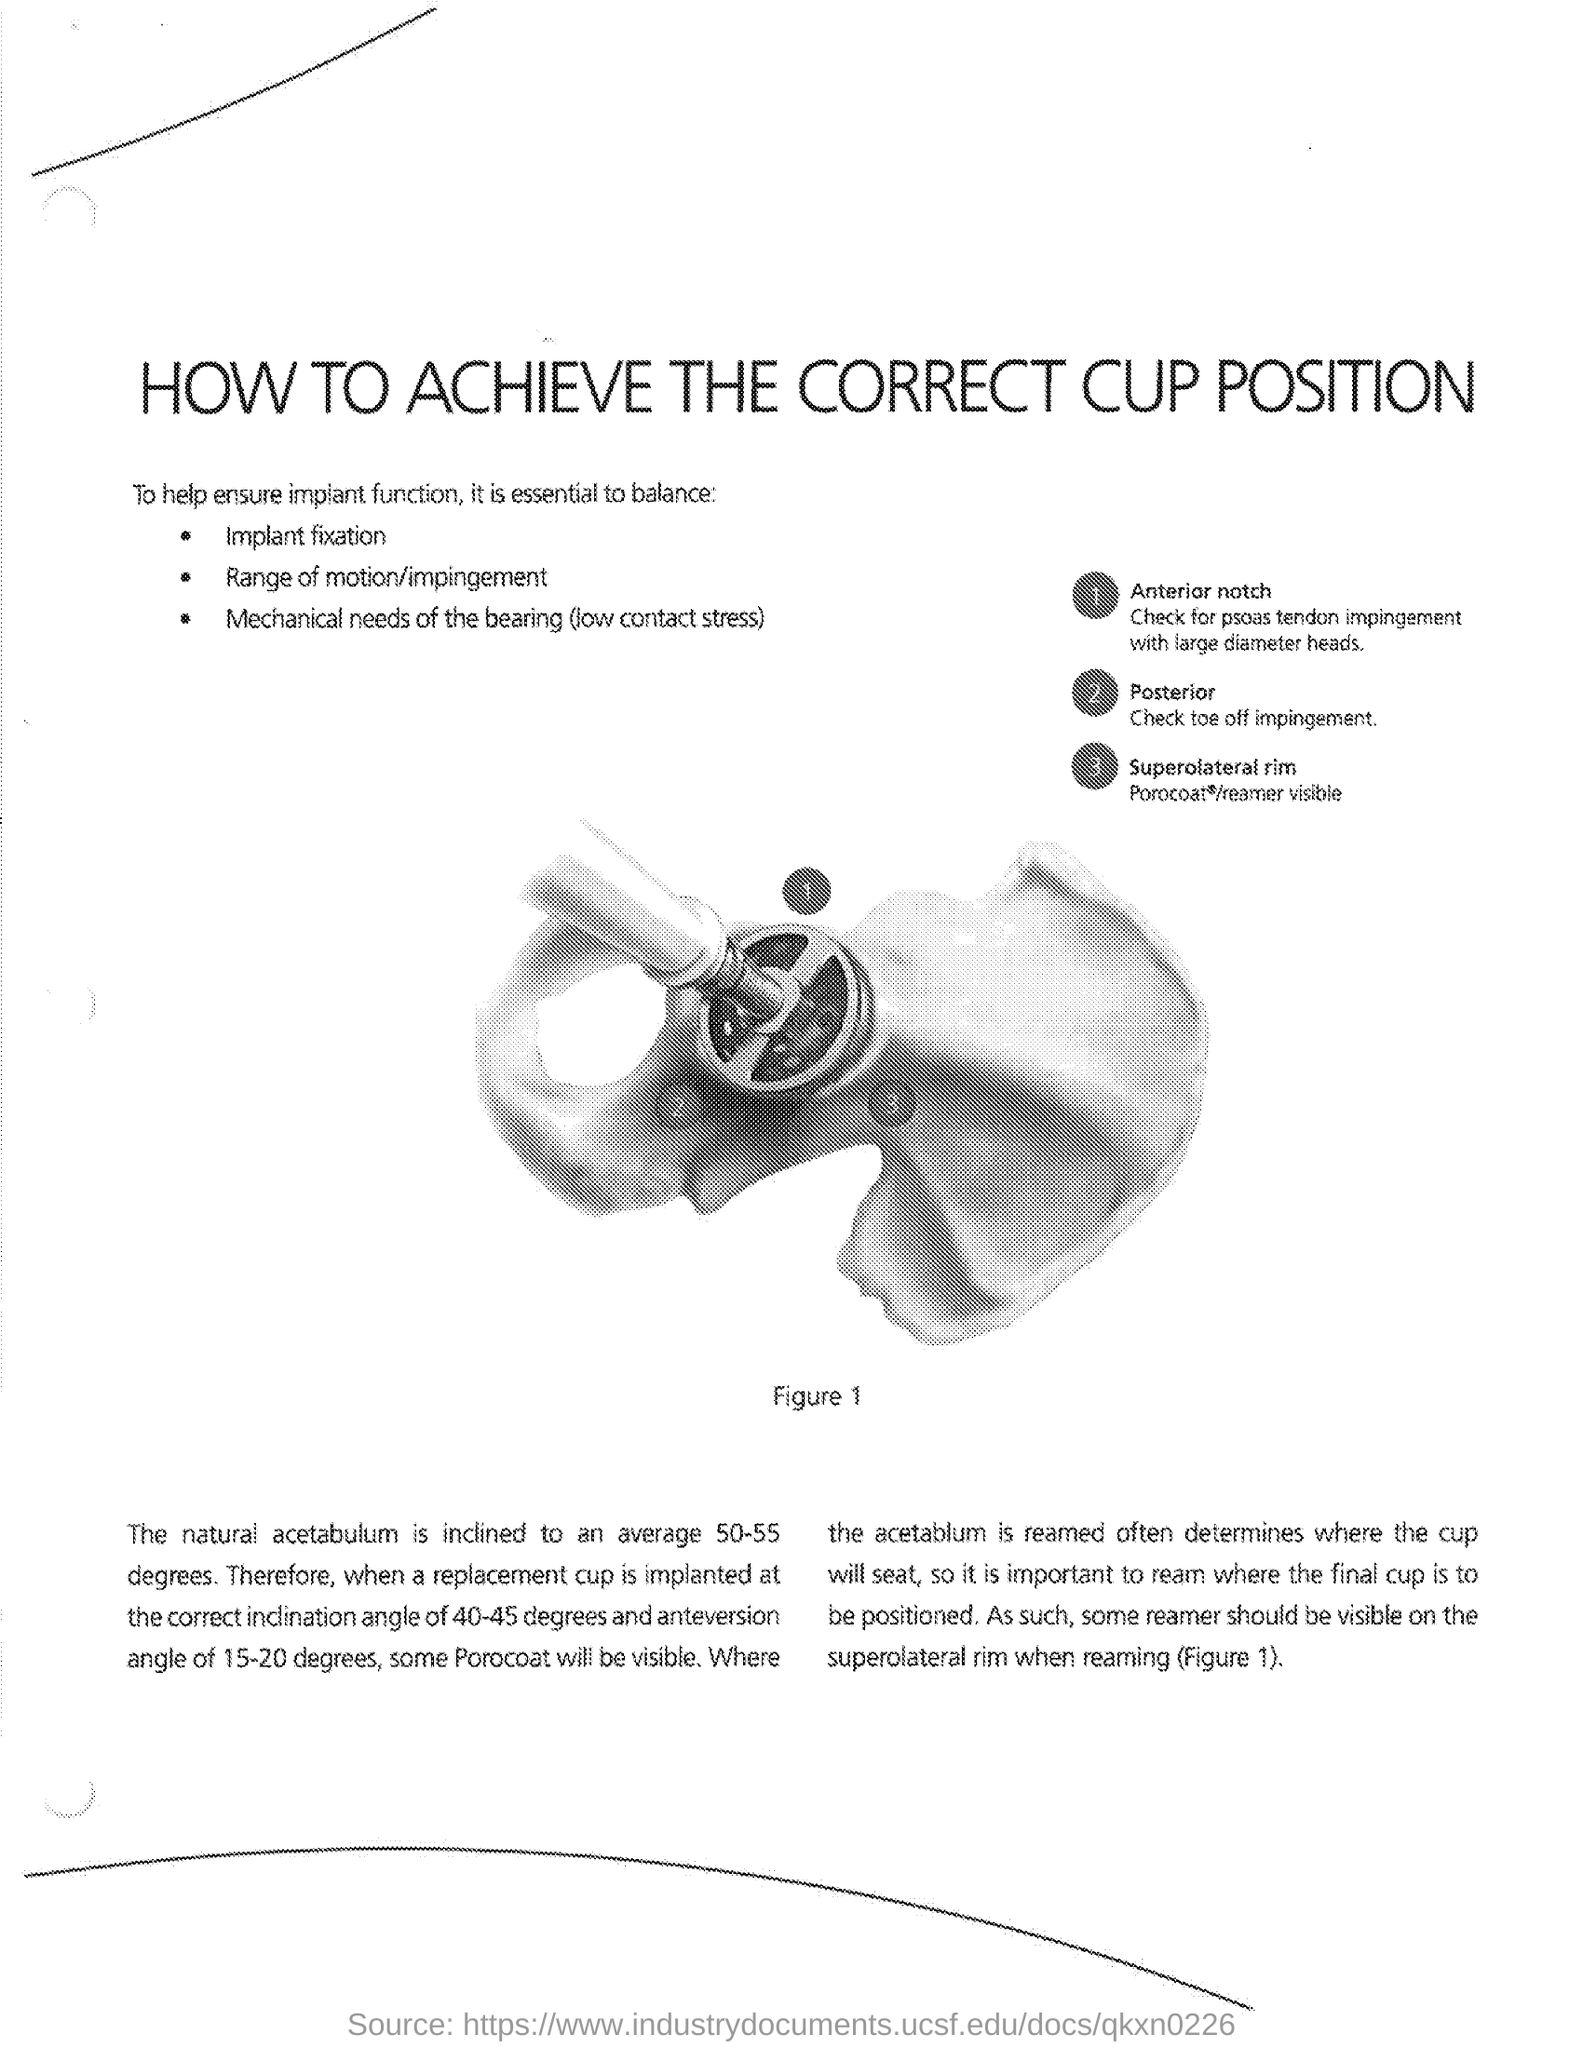What is the title of the document?
Provide a short and direct response. How to achieve the correct cup position. 